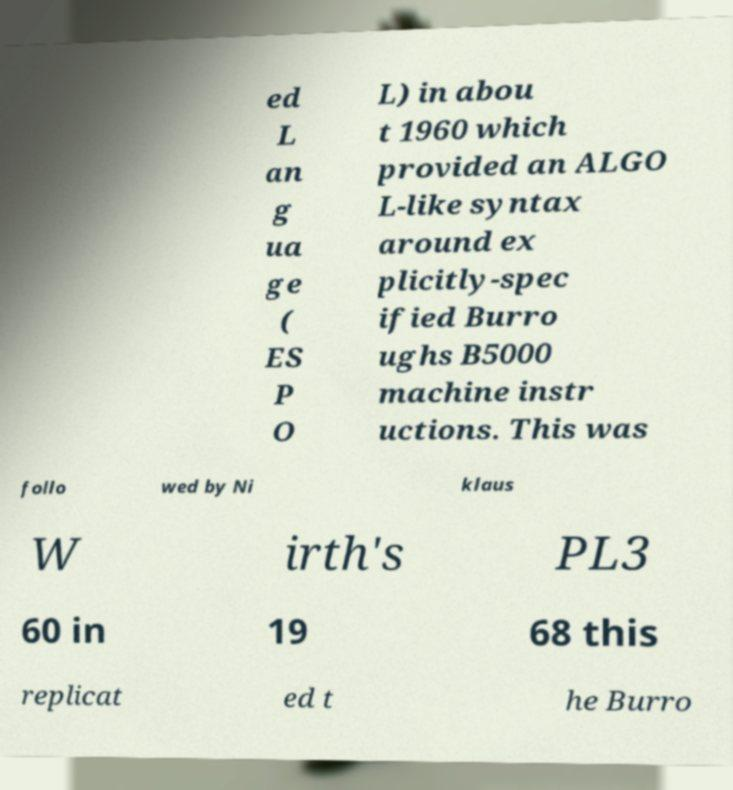Could you extract and type out the text from this image? ed L an g ua ge ( ES P O L) in abou t 1960 which provided an ALGO L-like syntax around ex plicitly-spec ified Burro ughs B5000 machine instr uctions. This was follo wed by Ni klaus W irth's PL3 60 in 19 68 this replicat ed t he Burro 